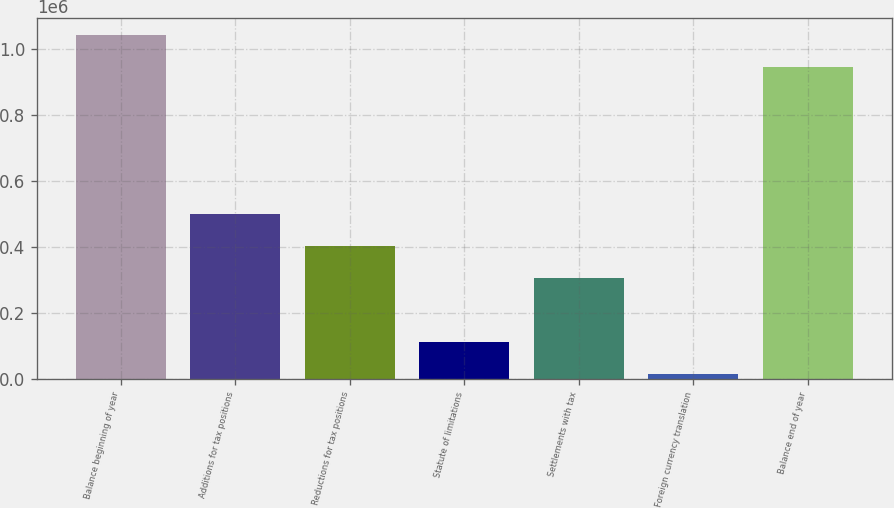Convert chart. <chart><loc_0><loc_0><loc_500><loc_500><bar_chart><fcel>Balance beginning of year<fcel>Additions for tax positions<fcel>Reductions for tax positions<fcel>Statute of limitations<fcel>Settlements with tax<fcel>Foreign currency translation<fcel>Balance end of year<nl><fcel>1.04291e+06<fcel>500466<fcel>403409<fcel>112236<fcel>306351<fcel>15178<fcel>945850<nl></chart> 